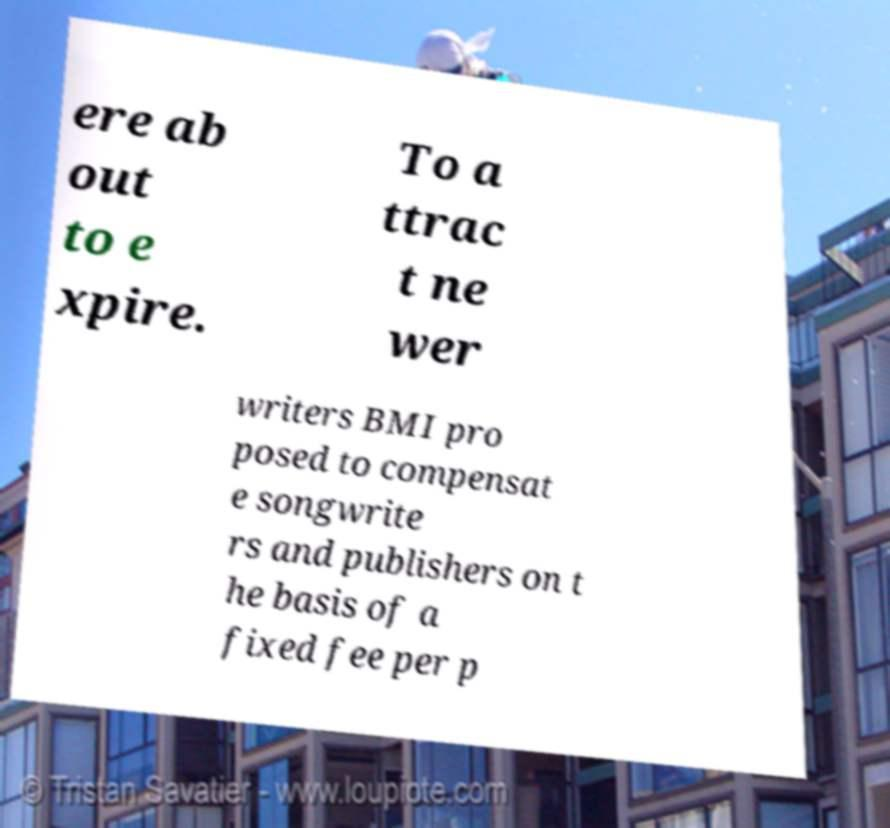Please read and relay the text visible in this image. What does it say? ere ab out to e xpire. To a ttrac t ne wer writers BMI pro posed to compensat e songwrite rs and publishers on t he basis of a fixed fee per p 